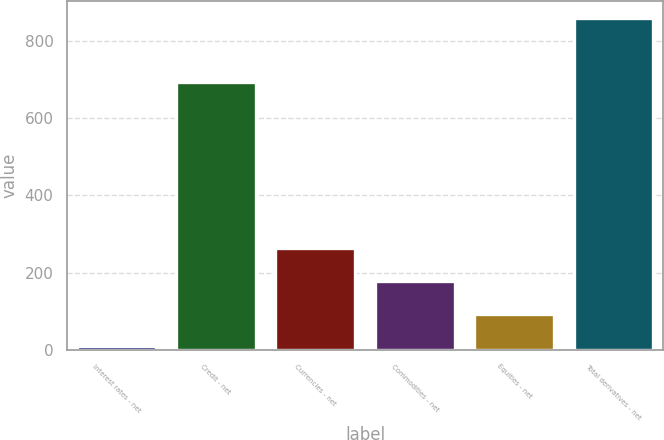Convert chart to OTSL. <chart><loc_0><loc_0><loc_500><loc_500><bar_chart><fcel>Interest rates - net<fcel>Credit - net<fcel>Currencies - net<fcel>Commodities - net<fcel>Equities - net<fcel>Total derivatives - net<nl><fcel>9<fcel>695<fcel>264.3<fcel>179.2<fcel>94.1<fcel>860<nl></chart> 